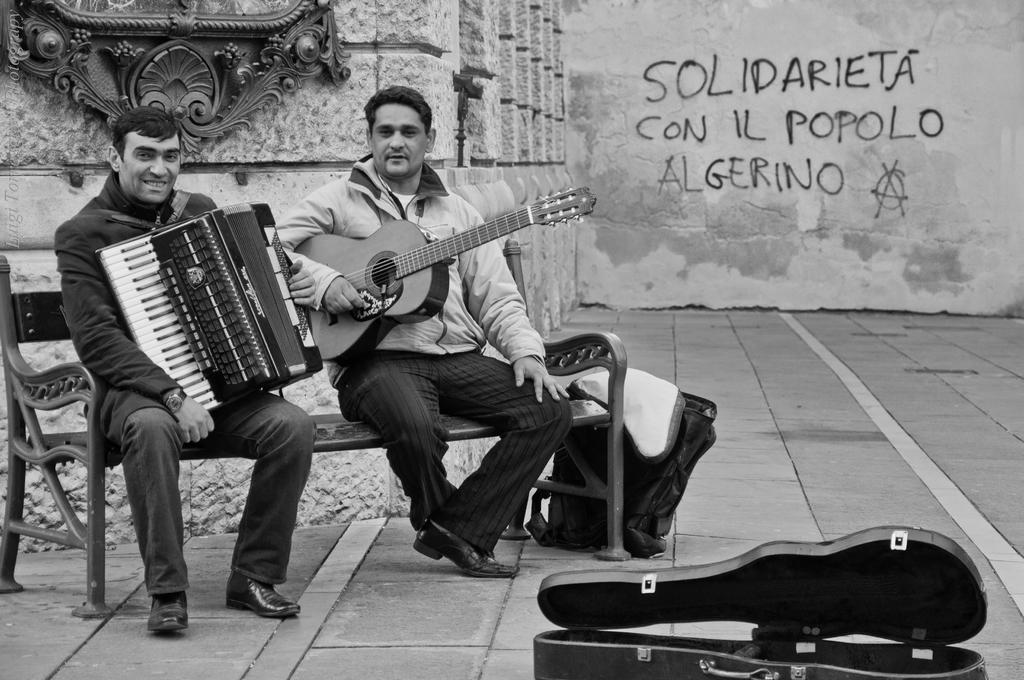How would you summarize this image in a sentence or two? To the left side there is a bench. On the bench there are two men sitting. To the left side there is a man with black jacket and playing piano. Beside him there is a man with white jacket and holding guitar. Beside him there is a bag. To the right bottom there is a guitar box. In the background there is a wall with sculpture on it. 